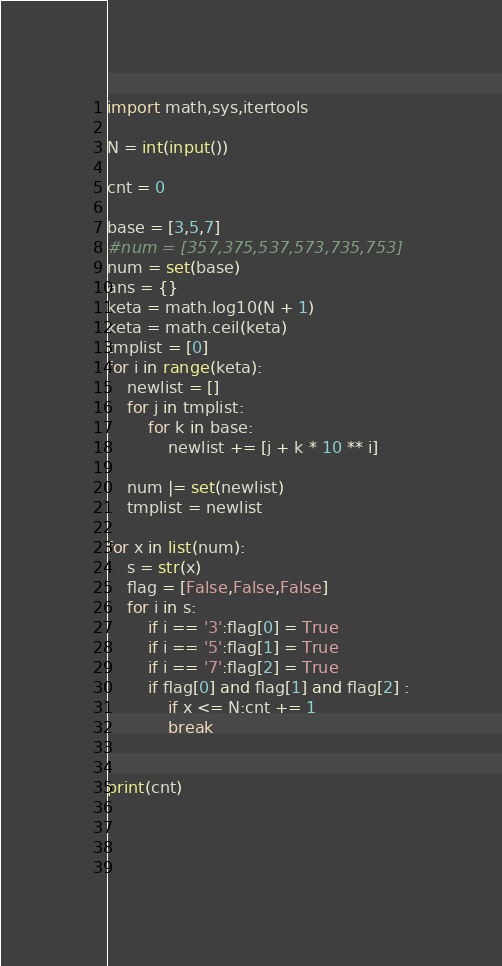Convert code to text. <code><loc_0><loc_0><loc_500><loc_500><_Python_>import math,sys,itertools

N = int(input())

cnt = 0

base = [3,5,7]
#num = [357,375,537,573,735,753]
num = set(base)
ans = {}
keta = math.log10(N + 1)
keta = math.ceil(keta) 
tmplist = [0]
for i in range(keta):
    newlist = []
    for j in tmplist:
        for k in base:
            newlist += [j + k * 10 ** i]
        
    num |= set(newlist)
    tmplist = newlist

for x in list(num):
    s = str(x)
    flag = [False,False,False]
    for i in s:
        if i == '3':flag[0] = True
        if i == '5':flag[1] = True
        if i == '7':flag[2] = True
        if flag[0] and flag[1] and flag[2] :
            if x <= N:cnt += 1            
            break
    

print(cnt)


        
        </code> 